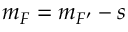<formula> <loc_0><loc_0><loc_500><loc_500>m _ { F } = m _ { F ^ { \prime } } - s</formula> 